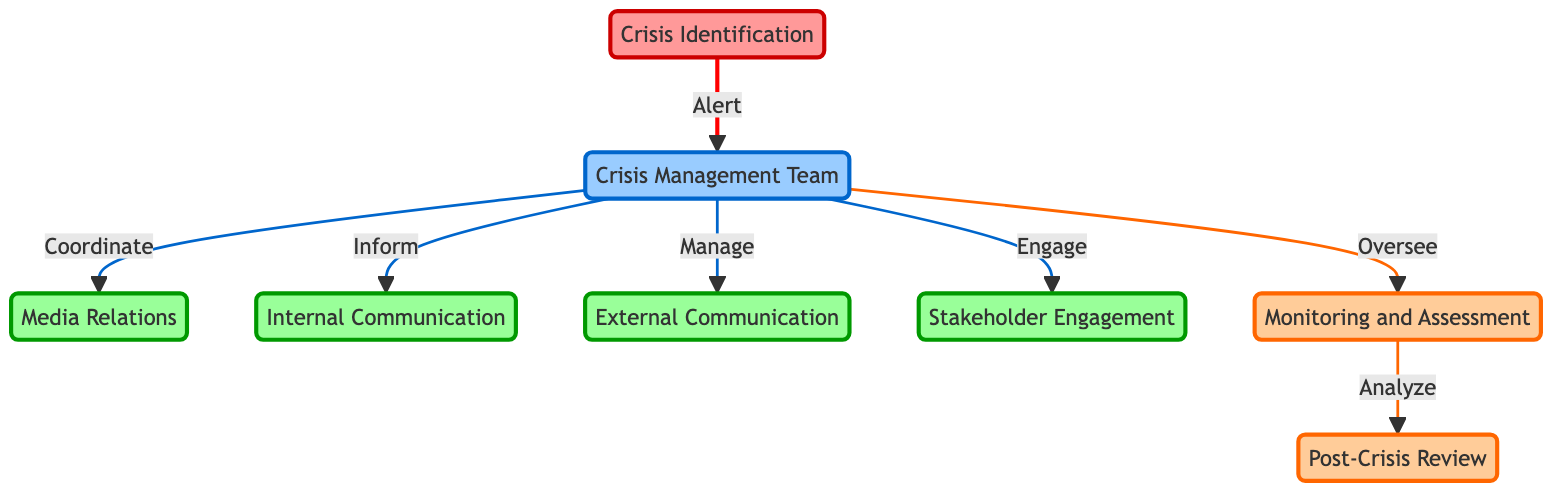What is the first step in the crisis management response plan? The first step is "Crisis Identification," as indicated by its position as the initial node in the directed graph and the absence of any incoming edges, showing it leads to the Crisis Management Team.
Answer: Crisis Identification How many nodes are present in the diagram? By counting the number of unique roles and components listed as nodes, the total comes to eight distinct entities present in the diagram.
Answer: Eight What role does the Crisis Management Team play in the communication process? The Crisis Management Team acts as a coordinator for Media Relations, informs Internal Communication, manages External Communication, engages Stakeholder Engagement, and oversees Monitoring, as these relationships stem from the Crisis Management Team in the directed graph.
Answer: Coordinator Which node follows the Monitoring node in the diagram? The node that follows Monitoring is Post-Crisis Review, as indicated by the directed edge that connects Monitoring to Post-Crisis Review directly in the graph structure.
Answer: Post-Crisis Review What is the relationship between Crisis Identification and Crisis Management Team? The relationship is that Crisis Identification alerts the Crisis Management Team, which is represented by a directed edge from the Crisis Identification node to the Crisis Management Team node in the diagram.
Answer: Alert How many edges are connecting to the Crisis Management Team? There are six edges connecting to the Crisis Management Team, as it has outgoing relationships to Media Relations, Internal Communication, External Communication, Stakeholder Engagement, and Monitoring, without any incoming edges.
Answer: Six What does the Monitoring node analyze? The Monitoring node analyzes the input data regarding the ongoing situation and generates insights that are later used in the Post-Crisis Review, as shown by the directed edge leading from Monitoring to Post-Crisis Review.
Answer: Post-Crisis Review What role does Media Relations have in the crisis management framework? Media Relations functions as a part of the overall communication strategy coordinated by the Crisis Management Team, indicating it is involved in managing communications with the media as depicted in the directed relationships.
Answer: Manage Which node does the Stakeholder Engagement connect to? The Stakeholder Engagement connects to the Crisis Management Team, indicated by an arrow directing from Crisis Management Team to Stakeholder Engagement in the diagram.
Answer: Crisis Management Team 